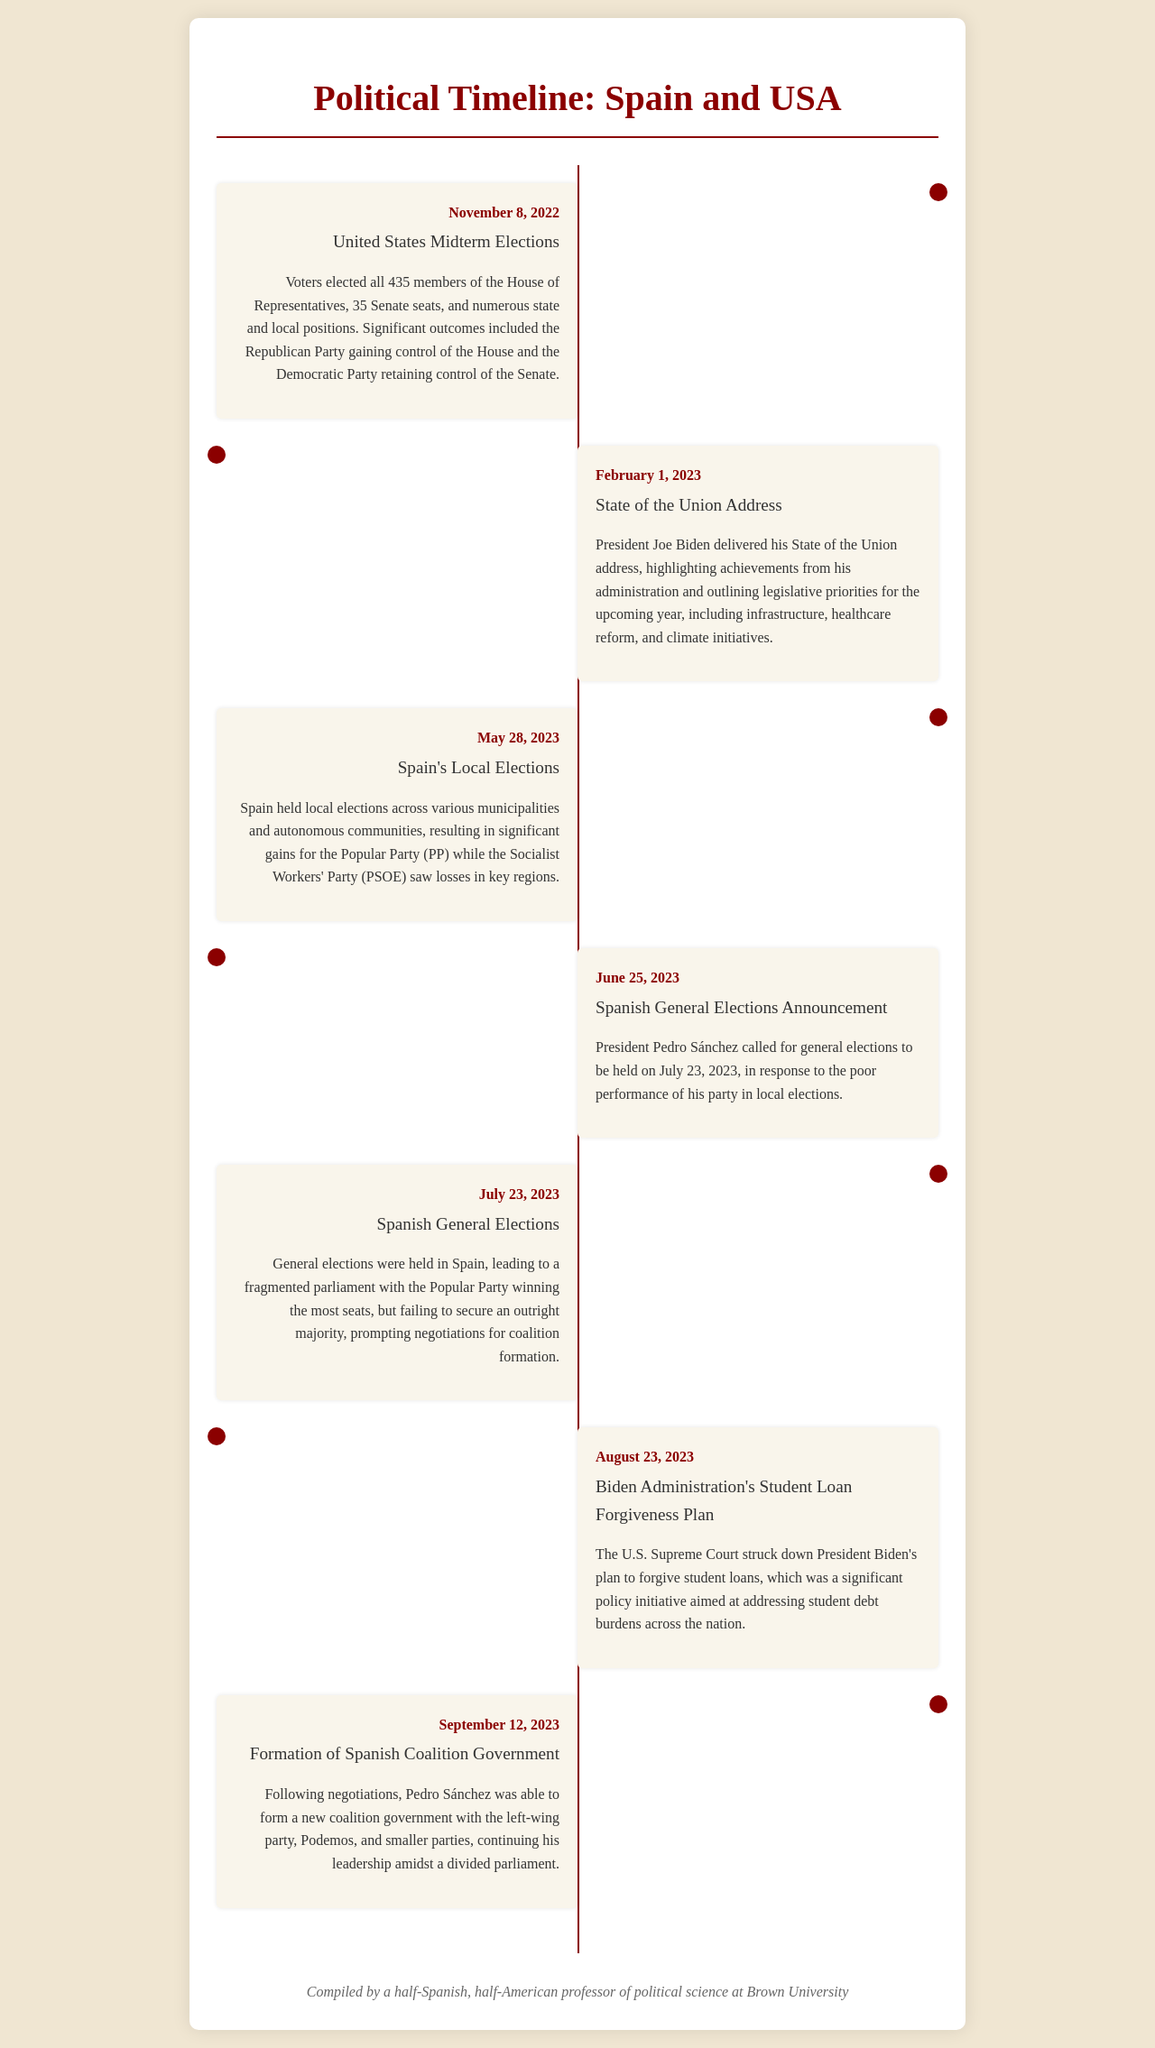What date were the United States Midterm Elections held? The document states that the United States Midterm Elections took place on November 8, 2022.
Answer: November 8, 2022 Which party gained control of the House in the United States Midterm Elections? According to the document, the Republican Party gained control of the House of Representatives.
Answer: Republican Party When did Spain hold local elections? The document mentions that Spain's local elections occurred on May 28, 2023.
Answer: May 28, 2023 What event led to the announcement of Spanish General Elections? The document indicates that the announcement of general elections was in response to the poor performance of the Socialist Workers' Party (PSOE) in local elections.
Answer: Poor performance of PSOE What was significant about the Spanish General Elections held on July 23, 2023? The document notes that the elections resulted in a fragmented parliament, with the Popular Party winning the most seats but not an outright majority.
Answer: Fragmented parliament Which major U.S. policy was struck down by the Supreme Court on August 23, 2023? The document states that the U.S. Supreme Court struck down President Biden's plan for student loan forgiveness.
Answer: Student loan forgiveness Who did Pedro Sánchez form a coalition government with? The document reveals that Pedro Sánchez formed a new coalition government with Podemos and smaller parties.
Answer: Podemos How many Senate seats were contested in the U.S. Midterm Elections? The document notes that 35 Senate seats were contested during the Midterm Elections.
Answer: 35 Senate seats 